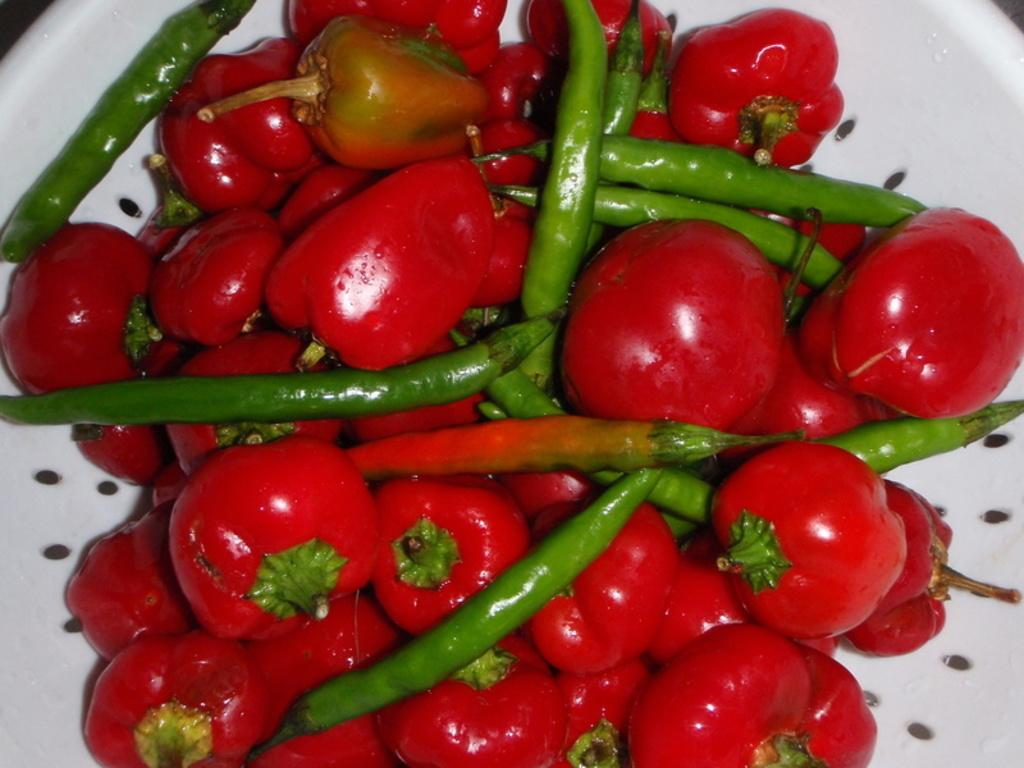What is in the bowl that is visible in the image? The bowl contains red chillies and green chillies. What color of chillies can be seen in the bowl? Both red and green chillies are visible in the bowl. How many frogs are sitting on the edge of the bowl in the image? There are no frogs present in the image; the bowl contains only red and green chillies. 